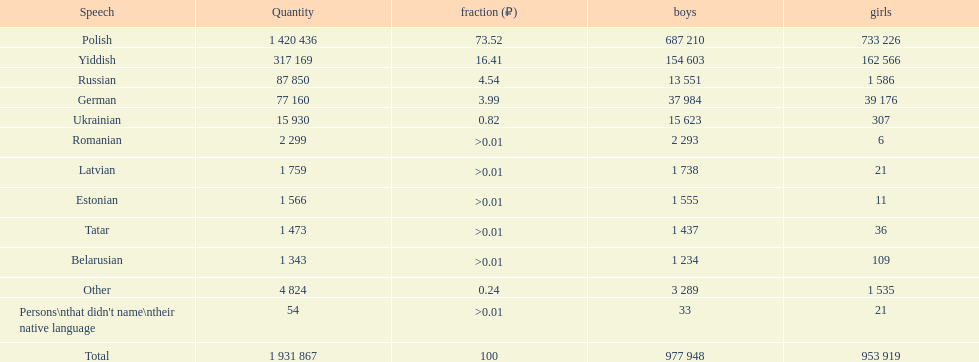Which language had the most number of people speaking it. Polish. 